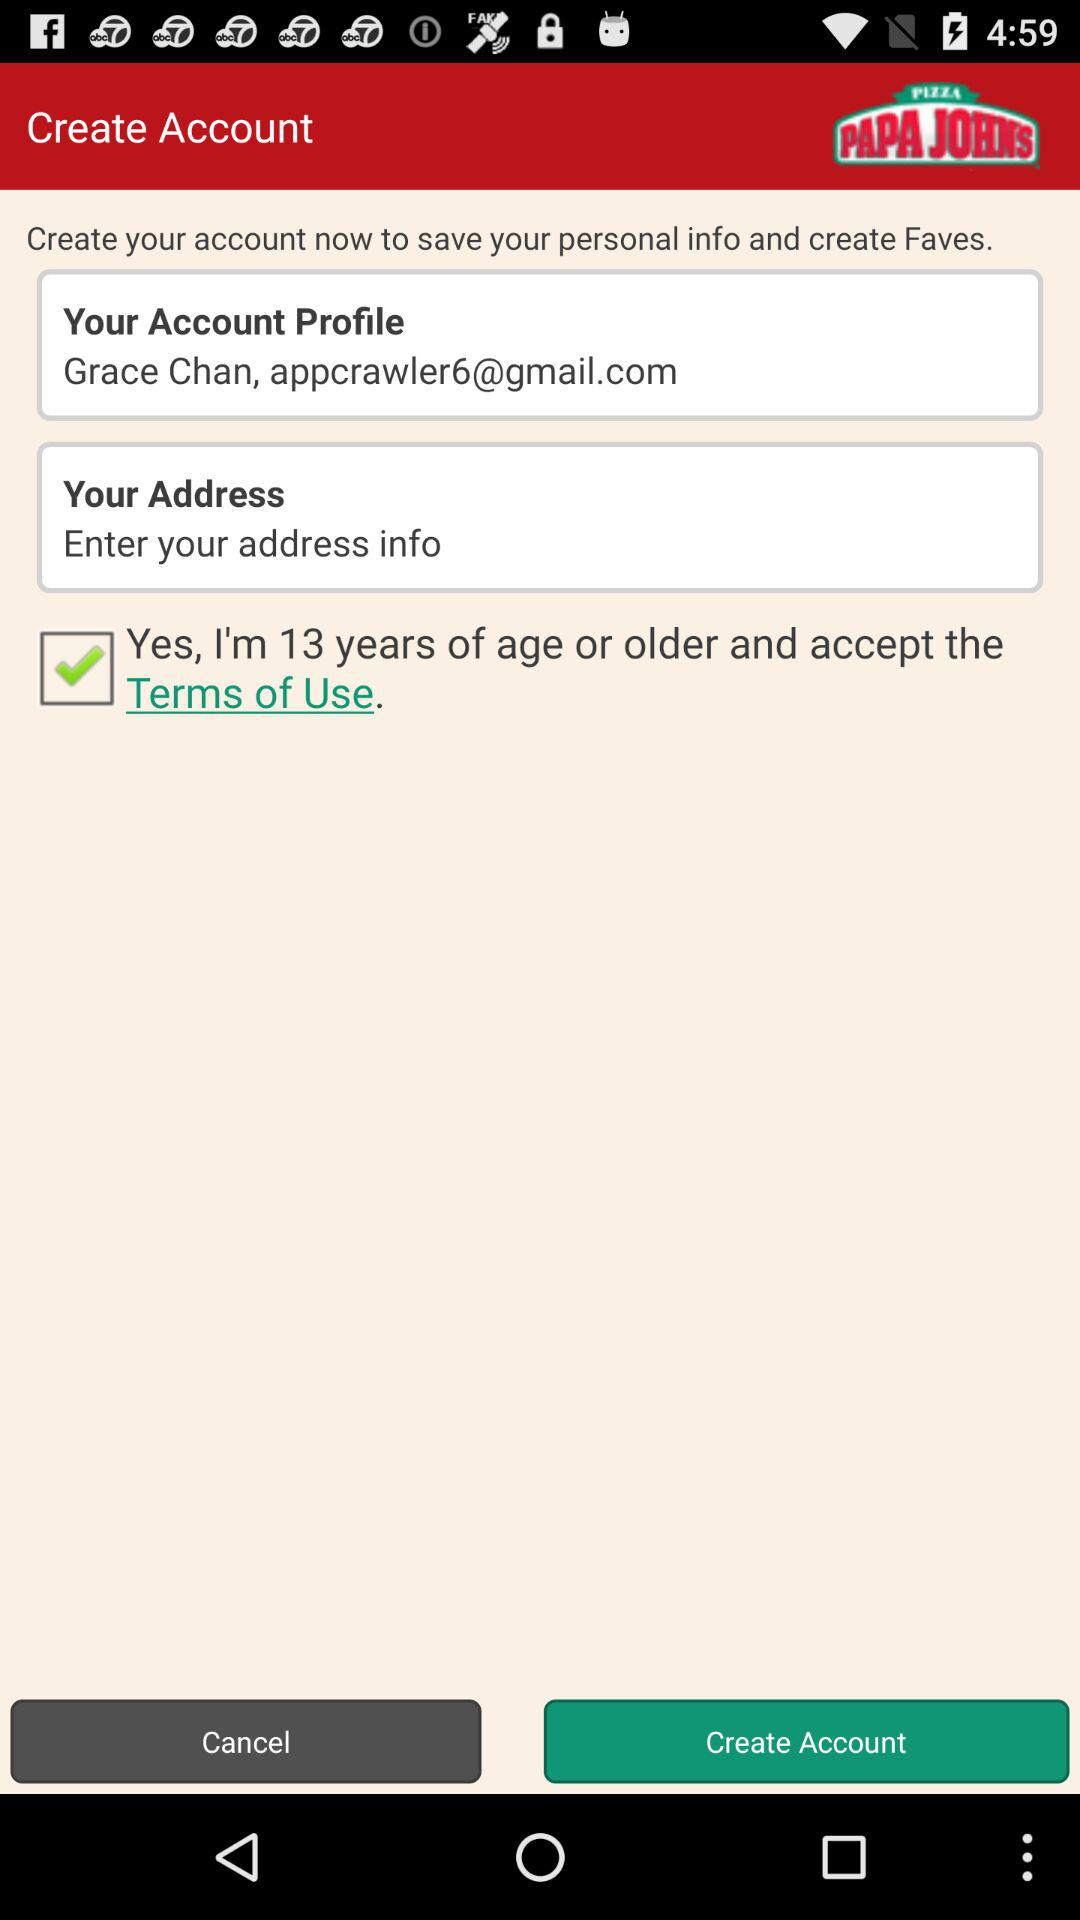What is the status of the option that includes acceptance to the "Terms of Use"? The status of the option is "on". 